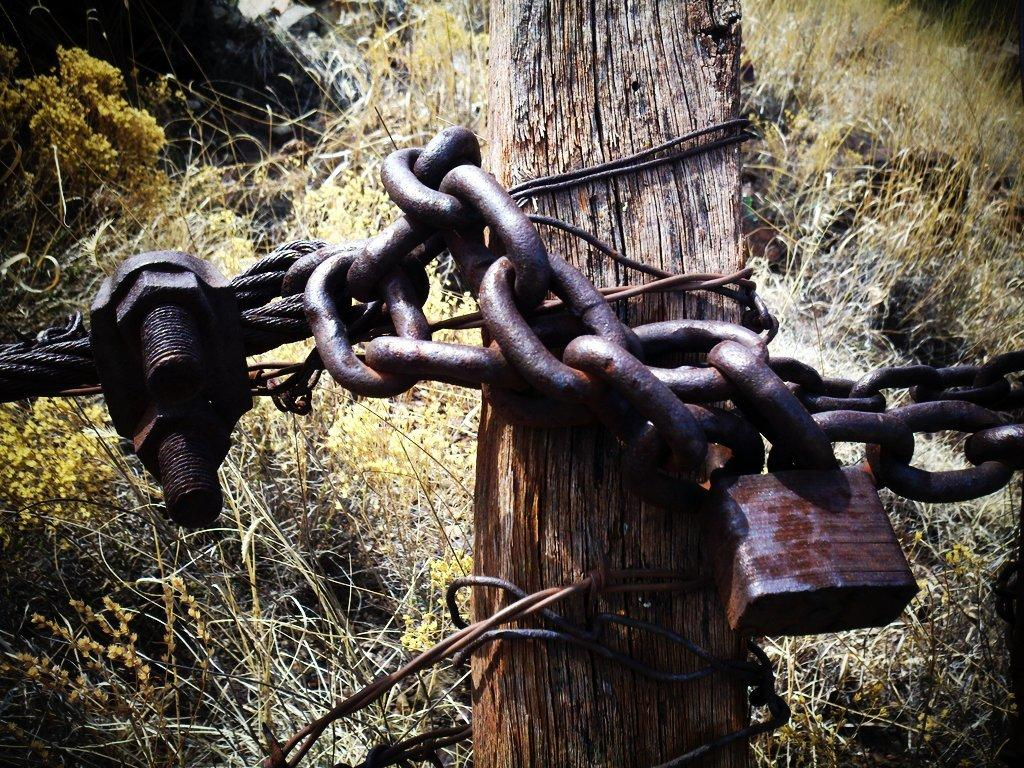What is attached to the wooden pole in the image? There is a chain and lock attached to the wooden pole in the image. What can be seen in the background of the image? Dry grass is visible in the background of the image. What type of animal can be seen attending the party in the image? There is no animal or party present in the image; it features a wooden pole with a chain and lock, and dry grass in the background. 